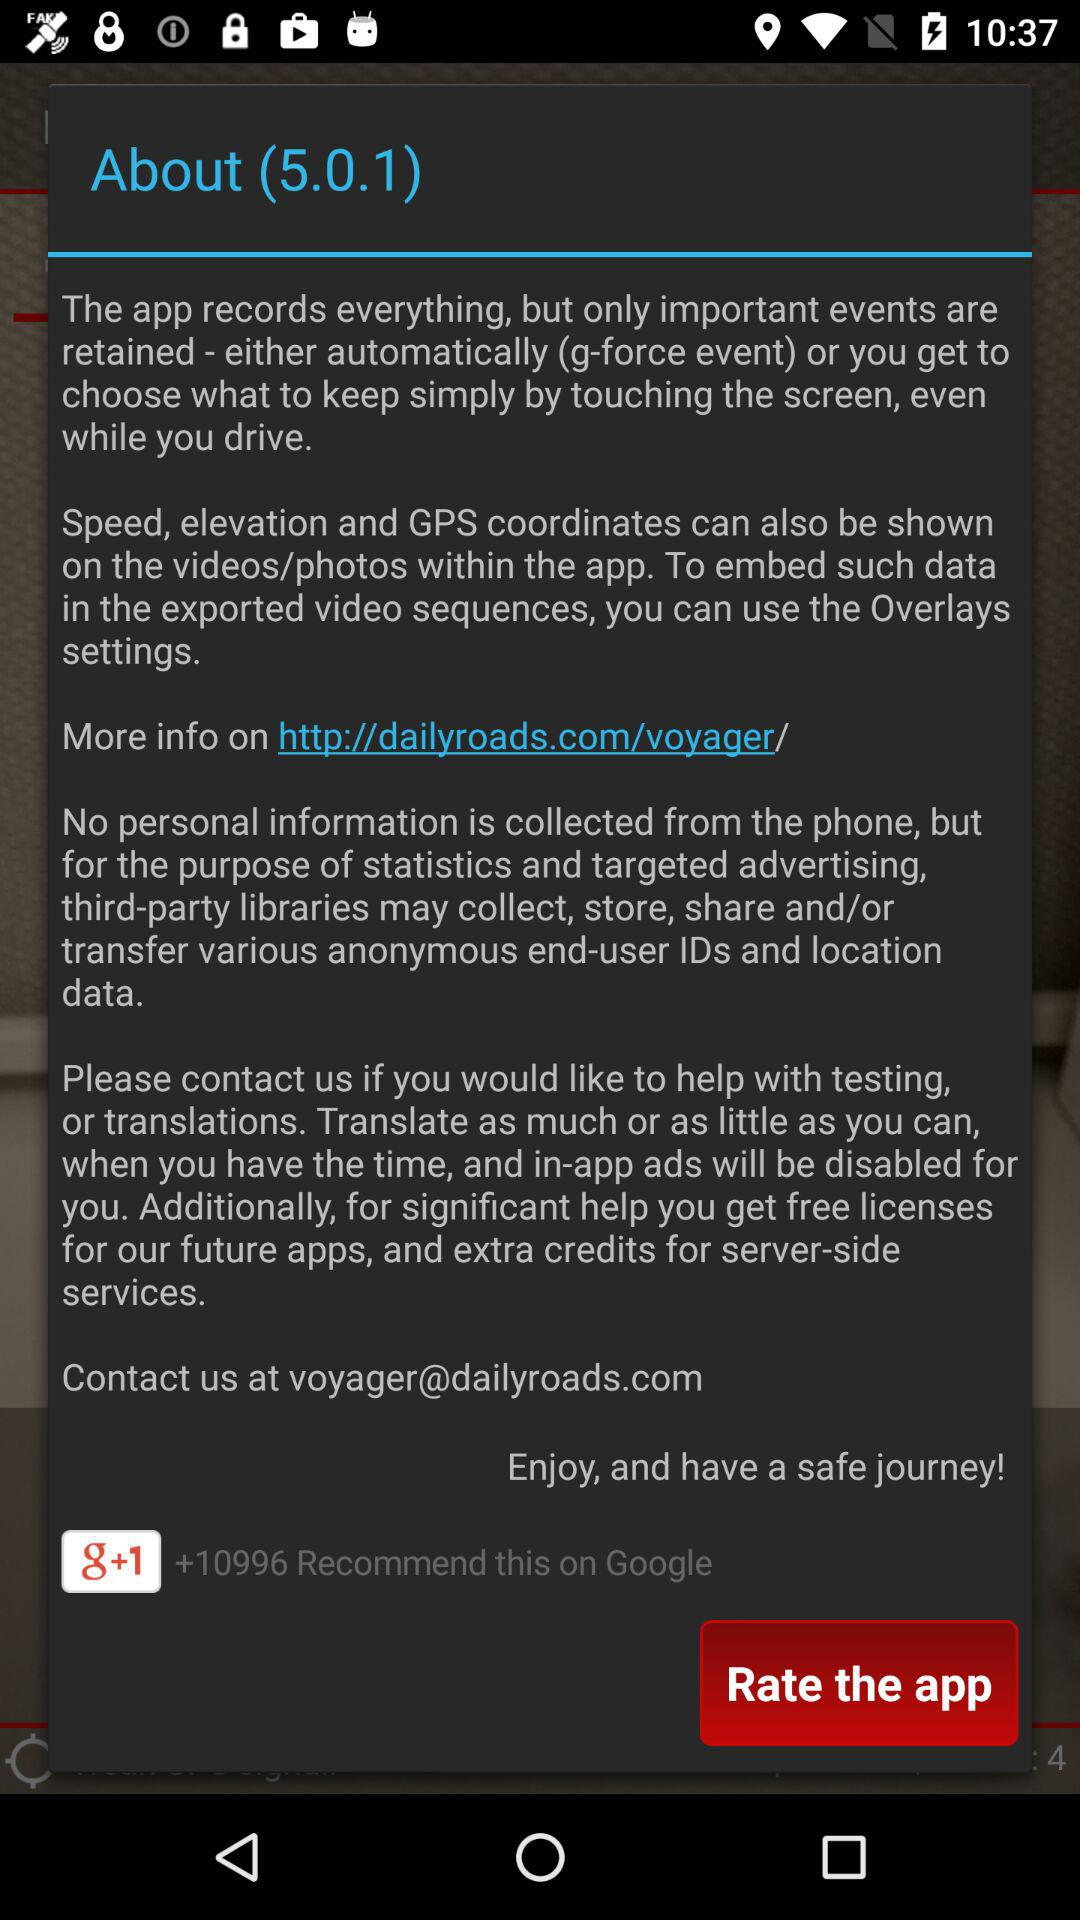How many people recommended this on Google? The number of people is +10996. 